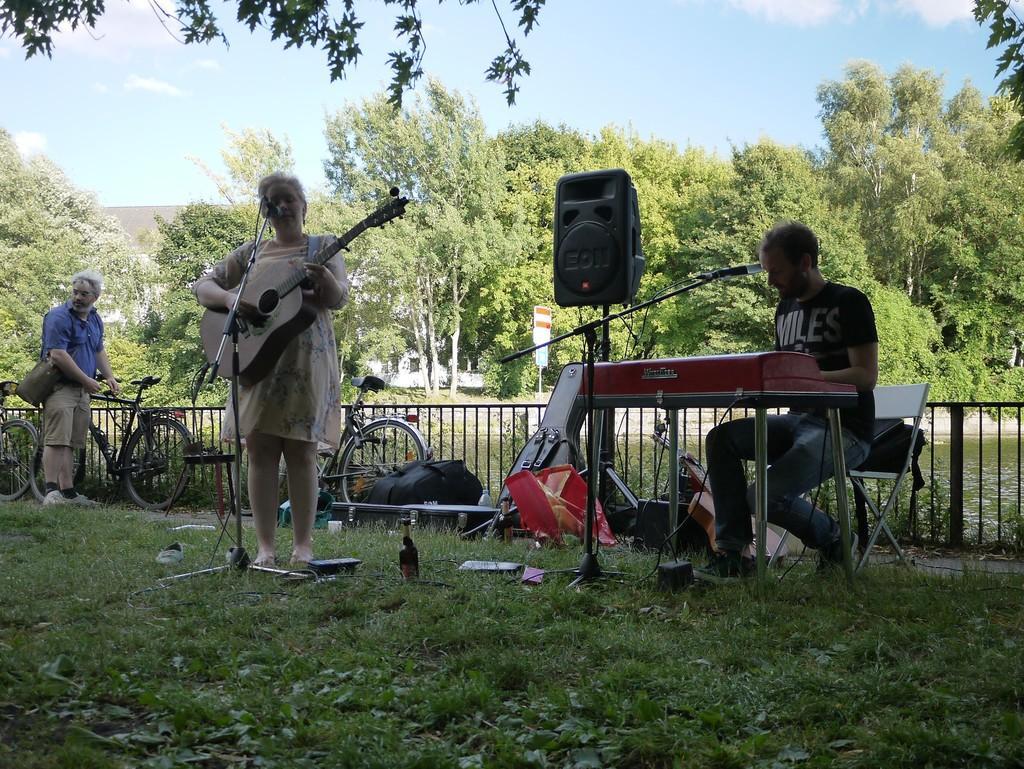Please provide a concise description of this image. In this image we can see two persons playing musical instruments. In front of the person we can see mics with stands and a bottle on the grass. Behind the person we can see a speaker, fencing, water, bicycle, a building and a group of trees. On the left side, we can see a person carrying a bag and holding the bicycle. At the top we can see the sky. 